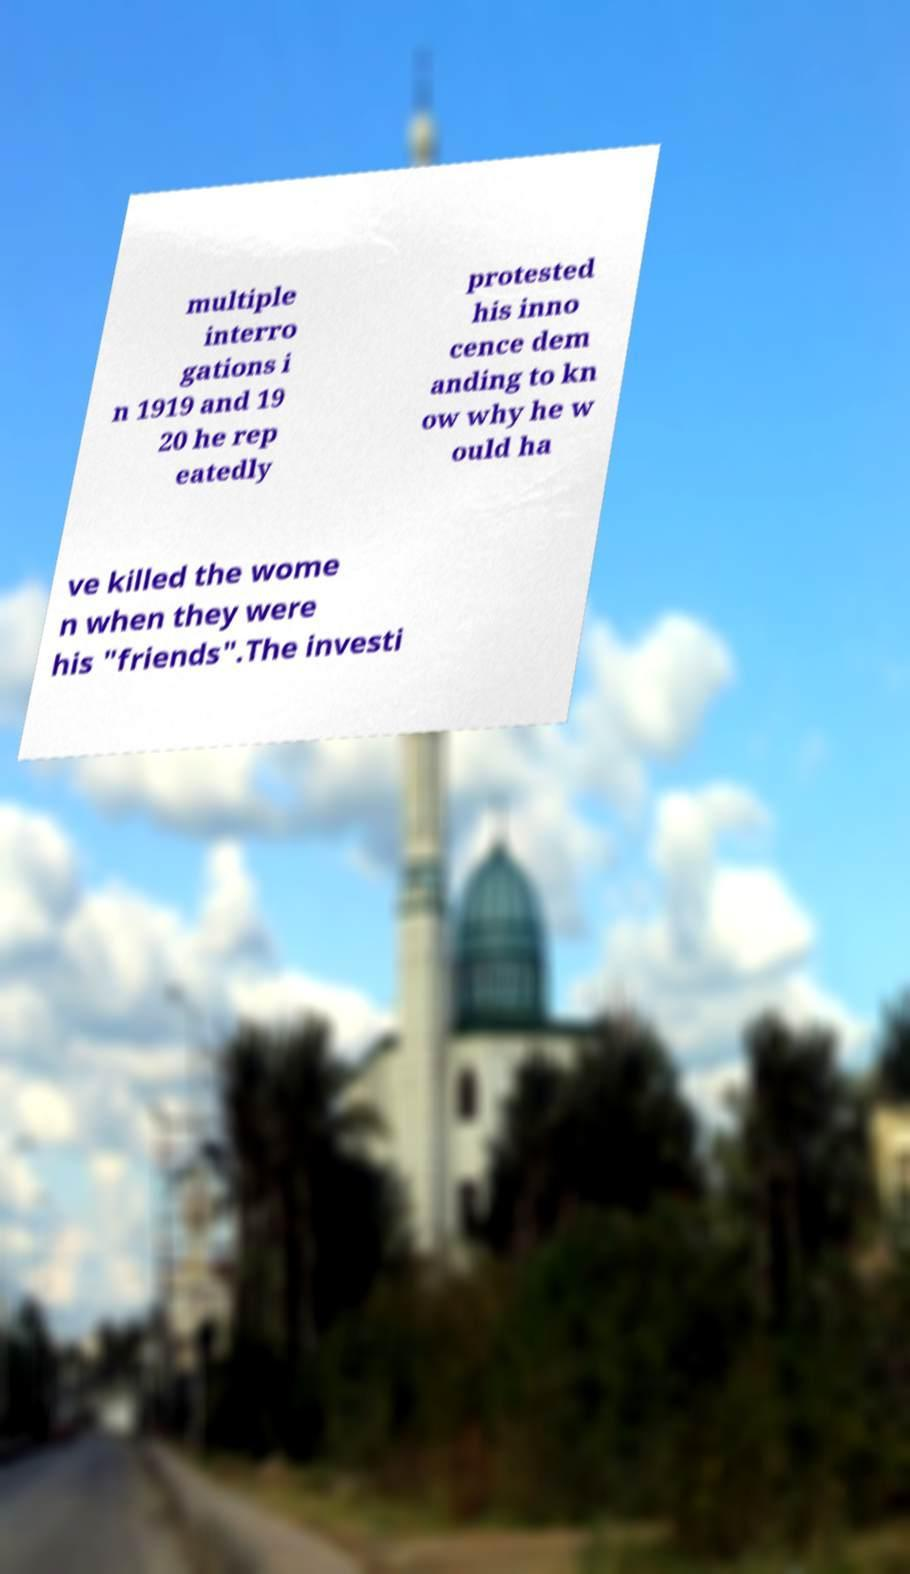Can you read and provide the text displayed in the image?This photo seems to have some interesting text. Can you extract and type it out for me? multiple interro gations i n 1919 and 19 20 he rep eatedly protested his inno cence dem anding to kn ow why he w ould ha ve killed the wome n when they were his "friends".The investi 